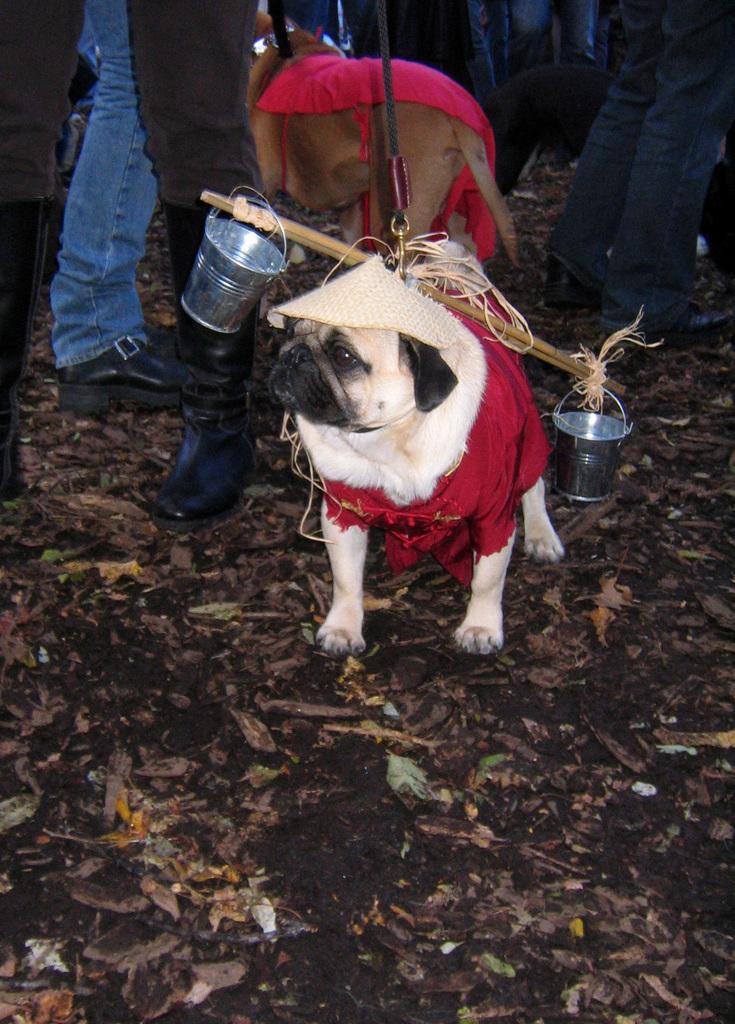How would you summarize this image in a sentence or two? In the picture we can see a dog on the surface and on the dog we can see a stick with two buckets are tied on the either sides and behind the dog we can see some people are standing and we can also see a part of a another dog with a red cloth on it. 